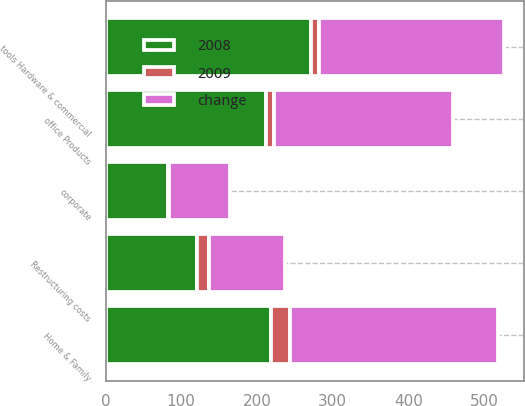Convert chart. <chart><loc_0><loc_0><loc_500><loc_500><stacked_bar_chart><ecel><fcel>Home & Family<fcel>office Products<fcel>tools Hardware & commercial<fcel>corporate<fcel>Restructuring costs<nl><fcel>change<fcel>274.7<fcel>235.2<fcel>245.6<fcel>80.6<fcel>100<nl><fcel>2008<fcel>218.3<fcel>212.4<fcel>271.7<fcel>81.9<fcel>120.3<nl><fcel>2009<fcel>25.8<fcel>10.7<fcel>9.6<fcel>1.6<fcel>16.9<nl></chart> 